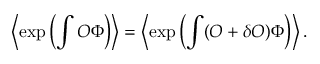Convert formula to latex. <formula><loc_0><loc_0><loc_500><loc_500>\left \langle \exp \left ( \int O \Phi \right ) \right \rangle = \left \langle \exp \left ( \int ( O + \delta O ) \Phi \right ) \right \rangle .</formula> 